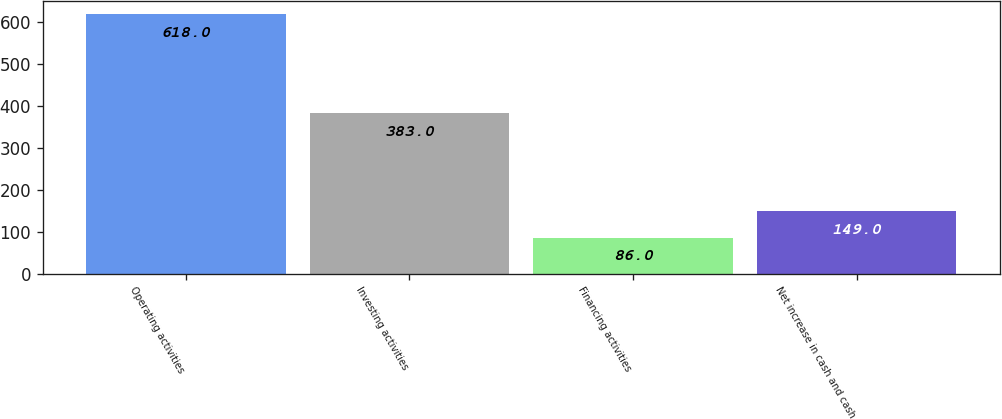Convert chart. <chart><loc_0><loc_0><loc_500><loc_500><bar_chart><fcel>Operating activities<fcel>Investing activities<fcel>Financing activities<fcel>Net increase in cash and cash<nl><fcel>618<fcel>383<fcel>86<fcel>149<nl></chart> 